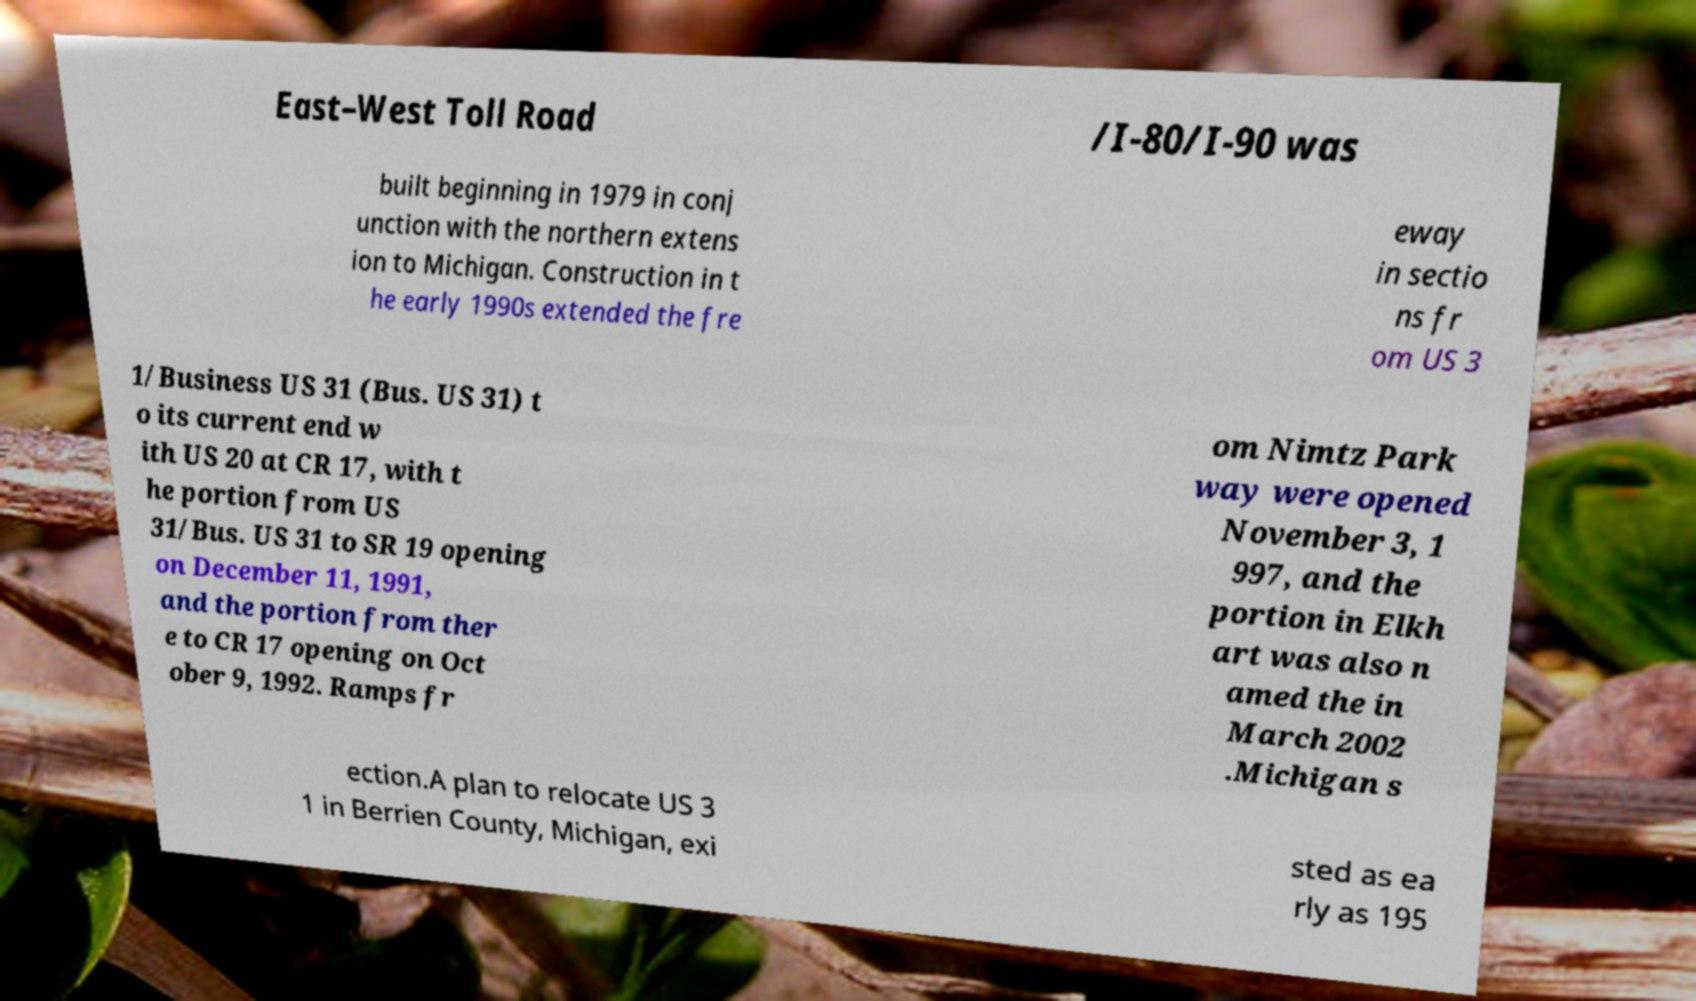Please read and relay the text visible in this image. What does it say? East–West Toll Road /I-80/I-90 was built beginning in 1979 in conj unction with the northern extens ion to Michigan. Construction in t he early 1990s extended the fre eway in sectio ns fr om US 3 1/Business US 31 (Bus. US 31) t o its current end w ith US 20 at CR 17, with t he portion from US 31/Bus. US 31 to SR 19 opening on December 11, 1991, and the portion from ther e to CR 17 opening on Oct ober 9, 1992. Ramps fr om Nimtz Park way were opened November 3, 1 997, and the portion in Elkh art was also n amed the in March 2002 .Michigan s ection.A plan to relocate US 3 1 in Berrien County, Michigan, exi sted as ea rly as 195 